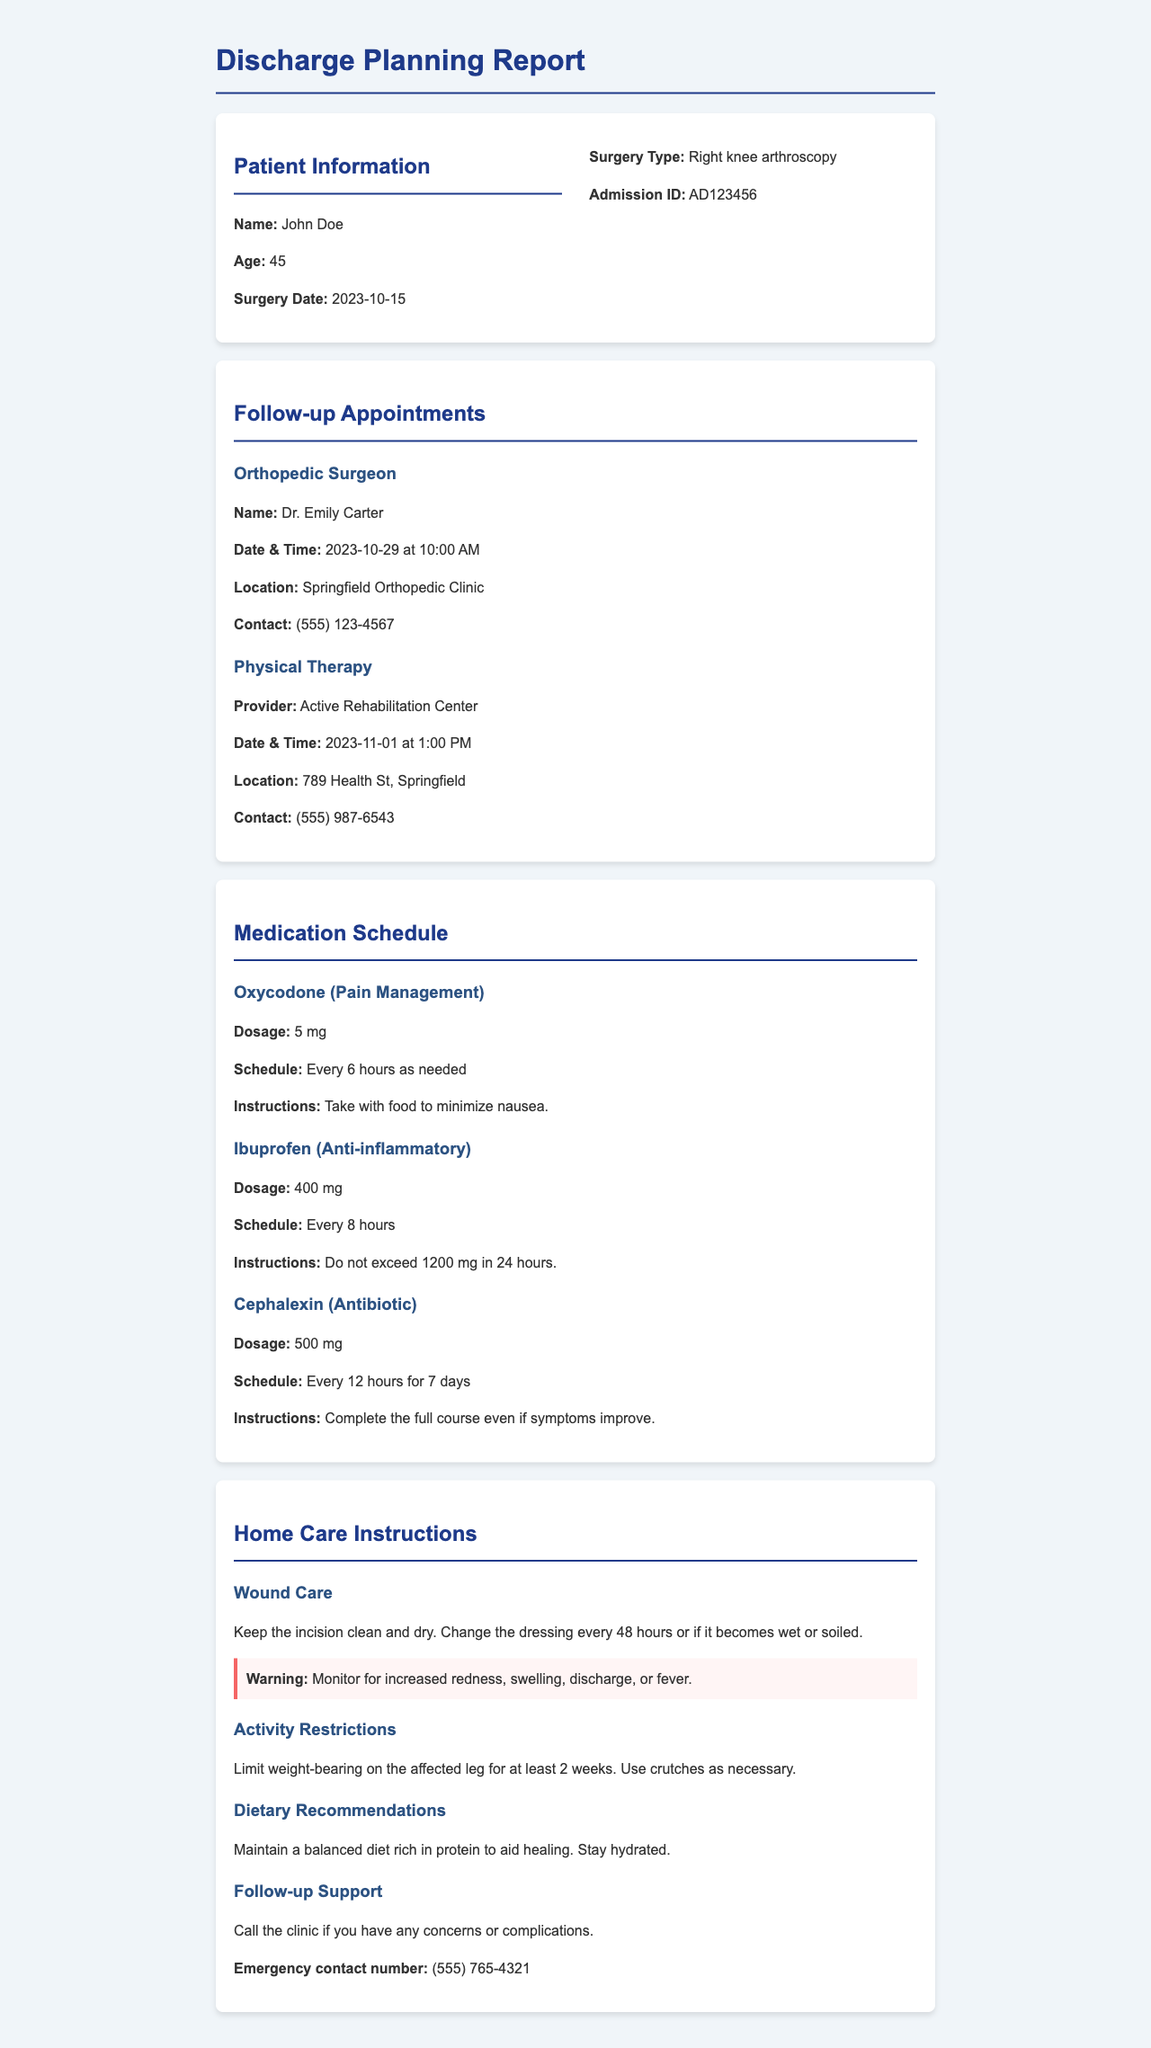What is the patient's name? The patient's name is listed at the top of the document under Patient Information.
Answer: John Doe What type of surgery did the patient undergo? The type of surgery is clearly stated in the Surgery Type section of the document.
Answer: Right knee arthroscopy When is the follow-up appointment with the orthopedic surgeon? The date and time of the follow-up appointment are detailed in the Follow-up Appointments section.
Answer: 2023-10-29 at 10:00 AM Who is the prescribing doctor for the medication Oxycodone? The medication details include the purpose, dosage, and instructions, as well as the prescribing doctor in the context of pain management.
Answer: Not specified How often should Ibuprofen be taken? The medication schedule for Ibuprofen is explicitly listed in the Medication Schedule section.
Answer: Every 8 hours What should the patient monitor for in terms of wound care? The warning section of the wound care instructions specifies what to look for post-surgery.
Answer: Increased redness, swelling, discharge, or fever What is the emergency contact number provided? The emergency contact number is stated in the Follow-up Support section under Home Care Instructions.
Answer: (555) 765-4321 How long should the patient limit weight-bearing on the affected leg? The Activity Restrictions give a clear time frame for how long weight-bearing should be limited.
Answer: At least 2 weeks 